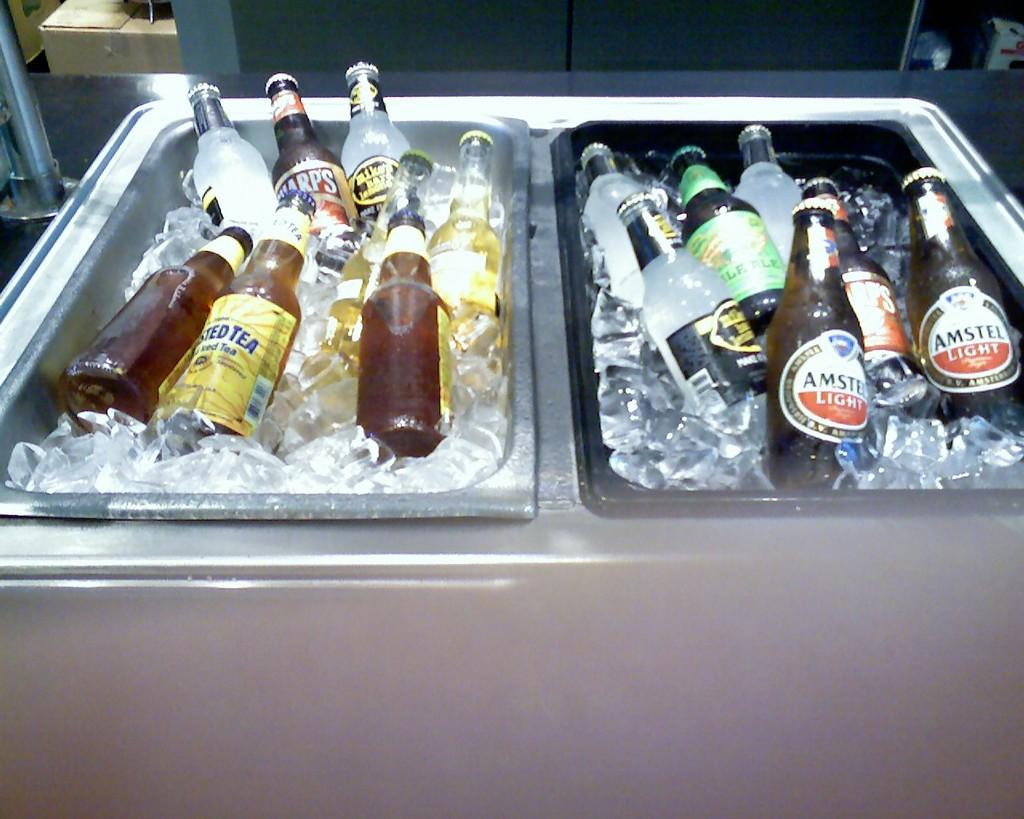<image>
Provide a brief description of the given image. Bottles of Amstel light are in a cooler with other bottles. 